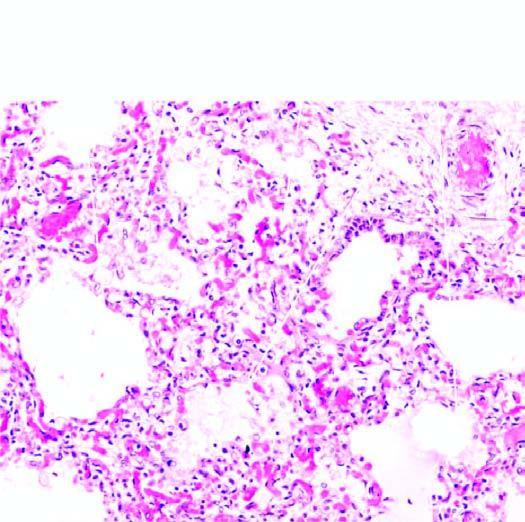what is there of septal walls while the air spaces contain pale oedema fluid and a few red cells?
Answer the question using a single word or phrase. Congestion 